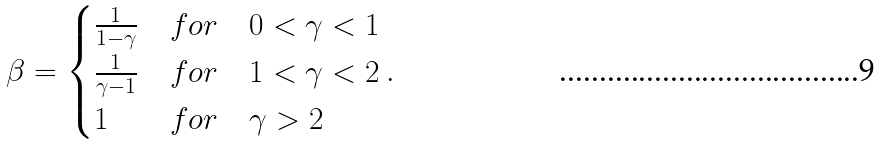Convert formula to latex. <formula><loc_0><loc_0><loc_500><loc_500>\beta = \begin{cases} \frac { 1 } { 1 - \gamma } & f o r \quad 0 < \gamma < 1 \\ \frac { 1 } { \gamma - 1 } & f o r \quad 1 < \gamma < 2 \\ 1 & f o r \quad \gamma > 2 \end{cases} .</formula> 